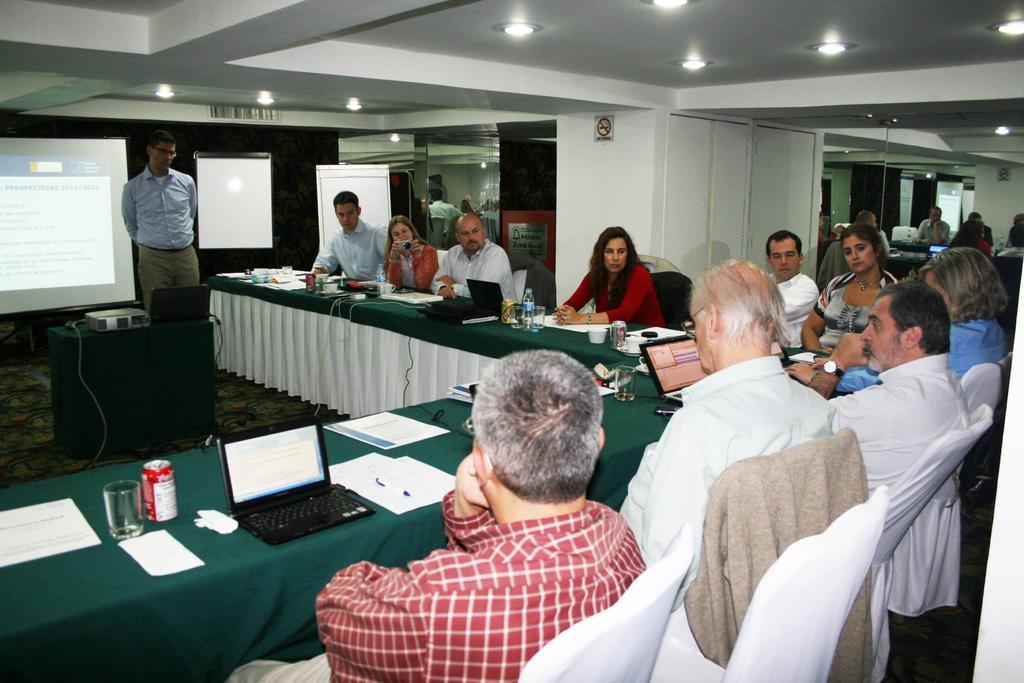Please provide a concise description of this image. In this picture we can see a group of people sitting on chairs and in front of them there is table and on table we can see papers, glass, tin, laptop, cup, bottle and in middle person is standing with projector beside to him on table and in background we can see screen, wall, glass, lights. 